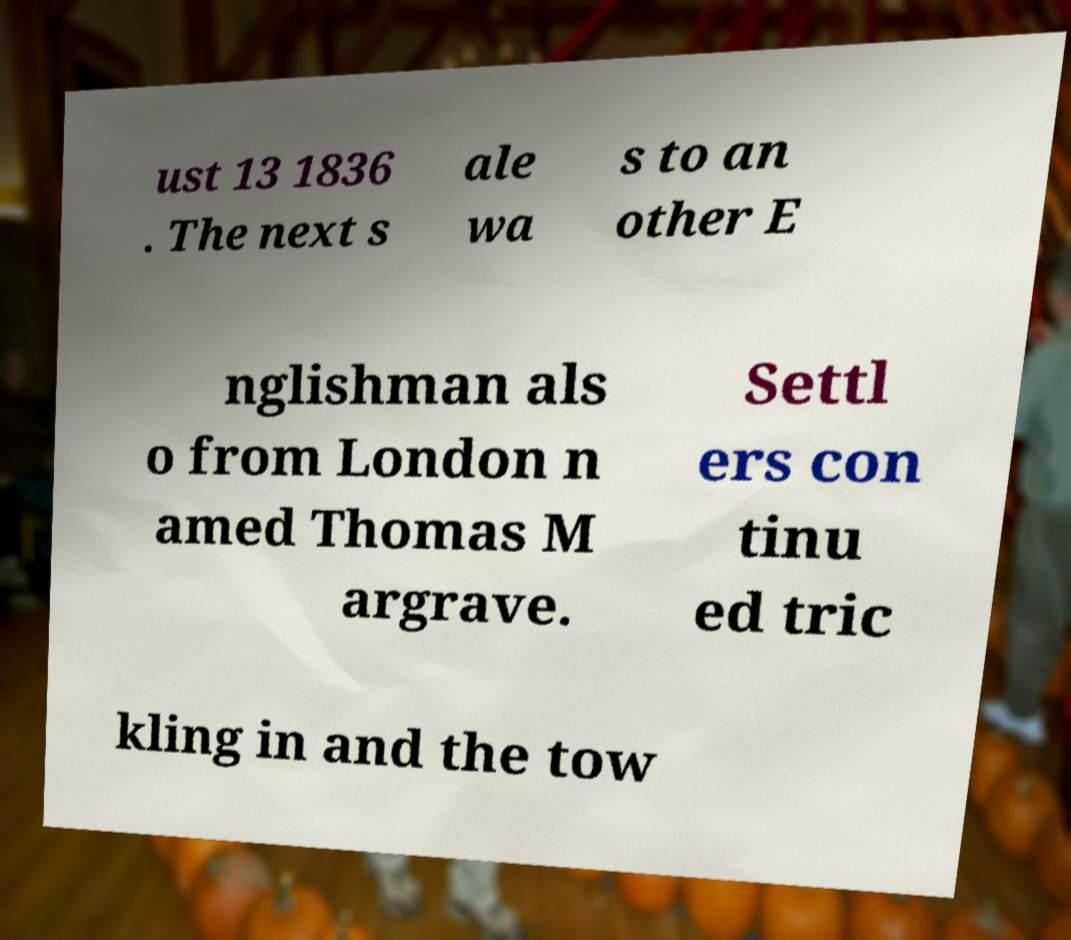Could you extract and type out the text from this image? ust 13 1836 . The next s ale wa s to an other E nglishman als o from London n amed Thomas M argrave. Settl ers con tinu ed tric kling in and the tow 